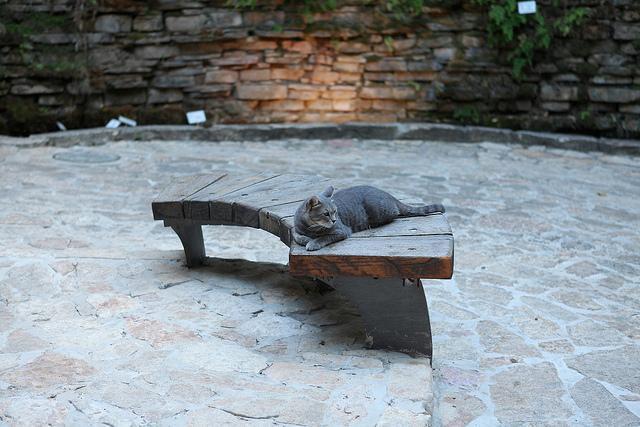How many animals are there?
Give a very brief answer. 1. How many donuts are there?
Give a very brief answer. 0. 